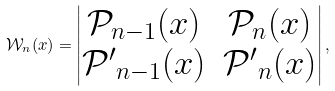Convert formula to latex. <formula><loc_0><loc_0><loc_500><loc_500>\mathcal { W } _ { n } ( x ) = \begin{vmatrix} \mathcal { P } _ { n - 1 } ( x ) & \mathcal { P } _ { n } ( x ) \\ \mathcal { P ^ { \prime } } _ { n - 1 } ( x ) & \mathcal { P ^ { \prime } } _ { n } ( x ) \end{vmatrix} ,</formula> 